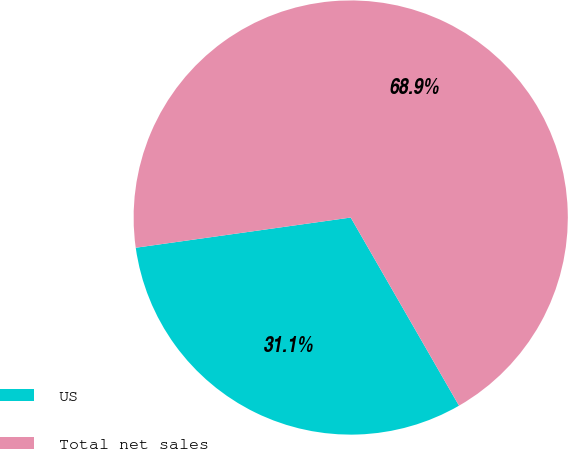Convert chart. <chart><loc_0><loc_0><loc_500><loc_500><pie_chart><fcel>US<fcel>Total net sales<nl><fcel>31.09%<fcel>68.91%<nl></chart> 